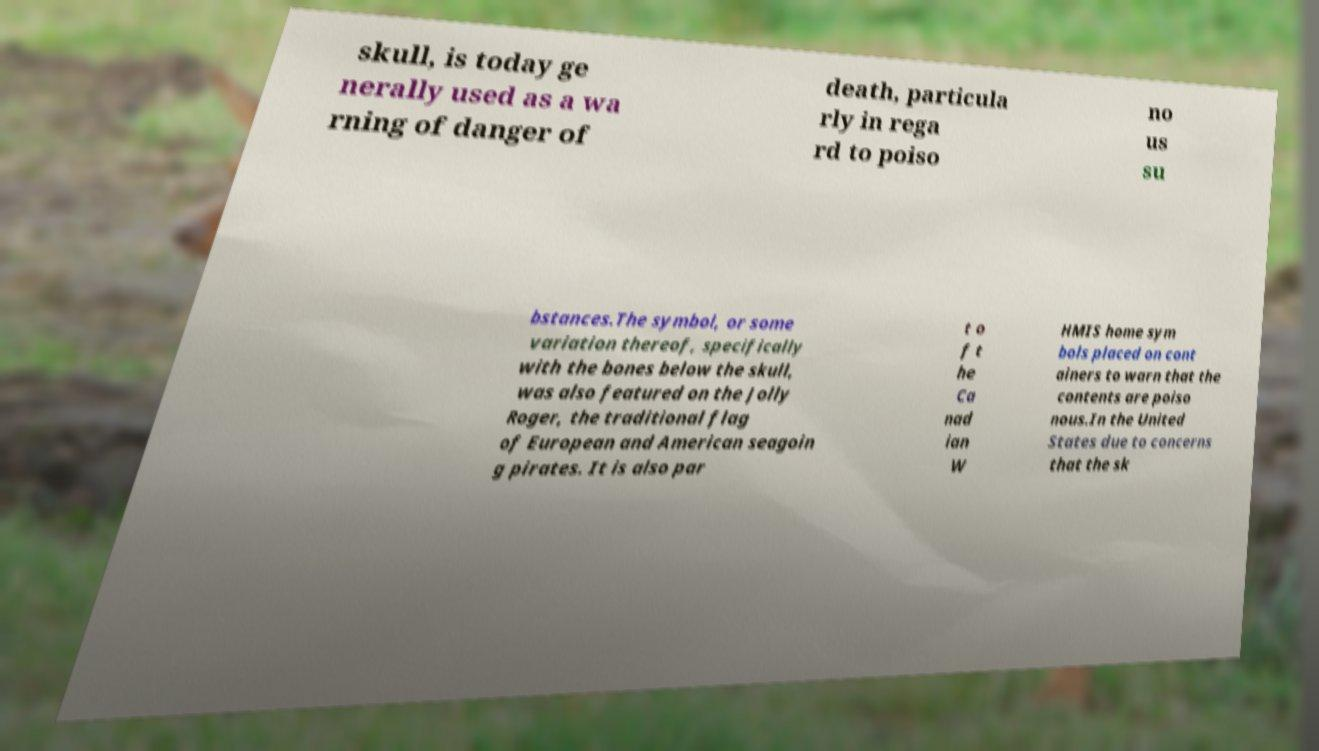Could you extract and type out the text from this image? skull, is today ge nerally used as a wa rning of danger of death, particula rly in rega rd to poiso no us su bstances.The symbol, or some variation thereof, specifically with the bones below the skull, was also featured on the Jolly Roger, the traditional flag of European and American seagoin g pirates. It is also par t o f t he Ca nad ian W HMIS home sym bols placed on cont ainers to warn that the contents are poiso nous.In the United States due to concerns that the sk 